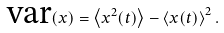<formula> <loc_0><loc_0><loc_500><loc_500>\text {var} ( x ) = \left < x ^ { 2 } ( t ) \right > - \left < x ( t ) \right > ^ { 2 } .</formula> 